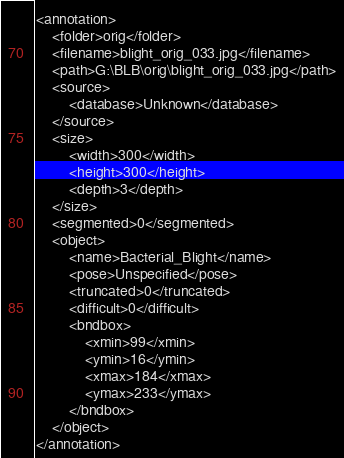<code> <loc_0><loc_0><loc_500><loc_500><_XML_><annotation>
	<folder>orig</folder>
	<filename>blight_orig_033.jpg</filename>
	<path>G:\BLB\orig\blight_orig_033.jpg</path>
	<source>
		<database>Unknown</database>
	</source>
	<size>
		<width>300</width>
		<height>300</height>
		<depth>3</depth>
	</size>
	<segmented>0</segmented>
	<object>
		<name>Bacterial_Blight</name>
		<pose>Unspecified</pose>
		<truncated>0</truncated>
		<difficult>0</difficult>
		<bndbox>
			<xmin>99</xmin>
			<ymin>16</ymin>
			<xmax>184</xmax>
			<ymax>233</ymax>
		</bndbox>
	</object>
</annotation>
</code> 